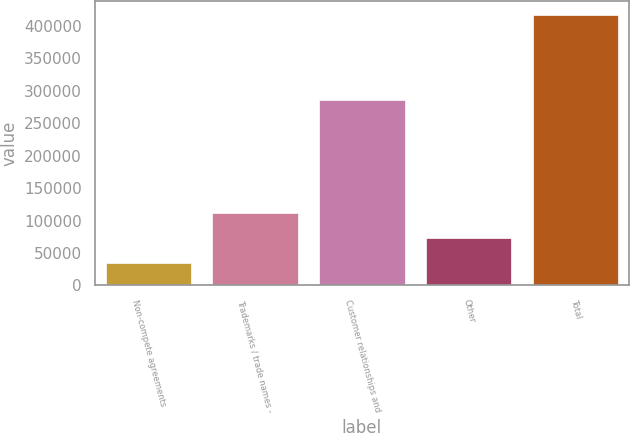<chart> <loc_0><loc_0><loc_500><loc_500><bar_chart><fcel>Non-compete agreements<fcel>Trademarks / trade names -<fcel>Customer relationships and<fcel>Other<fcel>Total<nl><fcel>34496<fcel>111023<fcel>285589<fcel>72759.7<fcel>417133<nl></chart> 